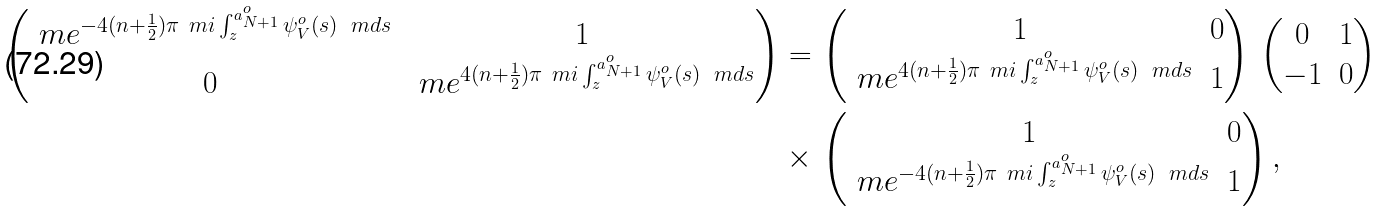<formula> <loc_0><loc_0><loc_500><loc_500>\begin{pmatrix} \ m e ^ { - 4 ( n + \frac { 1 } { 2 } ) \pi \ m i \int _ { z } ^ { a _ { N + 1 } ^ { o } } \psi _ { V } ^ { o } ( s ) \, \ m d s } & 1 \\ 0 & \ m e ^ { 4 ( n + \frac { 1 } { 2 } ) \pi \ m i \int _ { z } ^ { a _ { N + 1 } ^ { o } } \psi _ { V } ^ { o } ( s ) \, \ m d s } \end{pmatrix} = & \, \begin{pmatrix} 1 & 0 \\ \ m e ^ { 4 ( n + \frac { 1 } { 2 } ) \pi \ m i \int _ { z } ^ { a _ { N + 1 } ^ { o } } \psi _ { V } ^ { o } ( s ) \, \ m d s } & 1 \end{pmatrix} \, \begin{pmatrix} 0 & 1 \\ - 1 & 0 \end{pmatrix} \\ \times & \, \begin{pmatrix} 1 & 0 \\ \ m e ^ { - 4 ( n + \frac { 1 } { 2 } ) \pi \ m i \int _ { z } ^ { a _ { N + 1 } ^ { o } } \psi _ { V } ^ { o } ( s ) \, \ m d s } & 1 \end{pmatrix} ,</formula> 